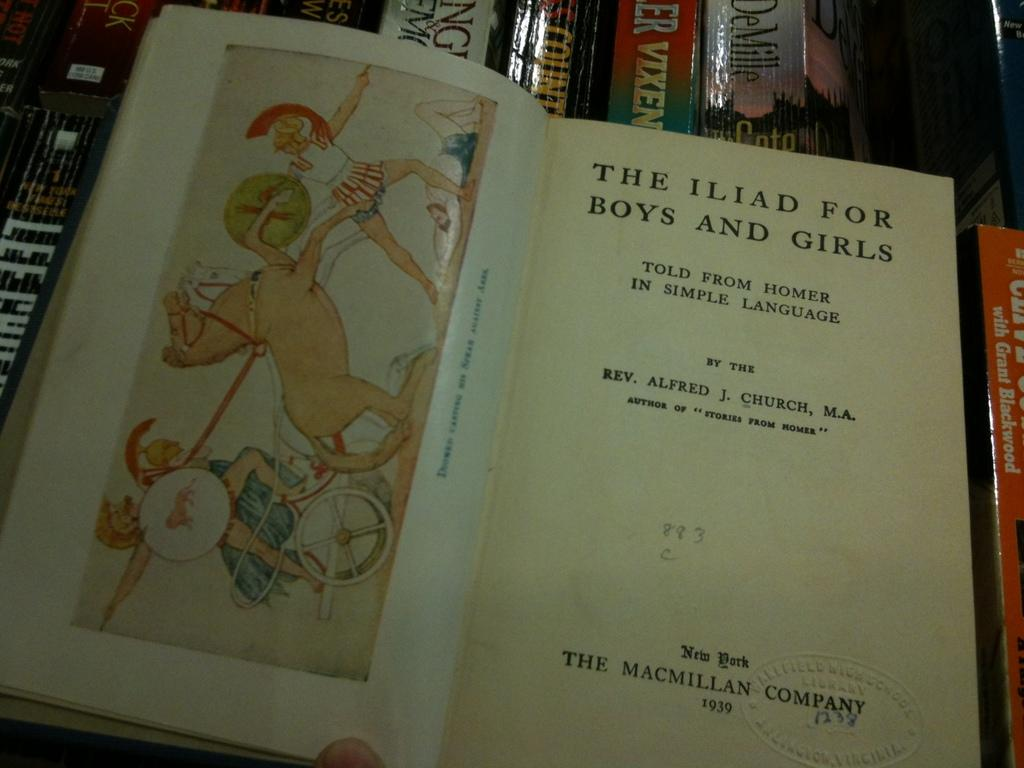<image>
Render a clear and concise summary of the photo. a book open and the words THE ILID FOR BOYS AND GIRLS at the top 